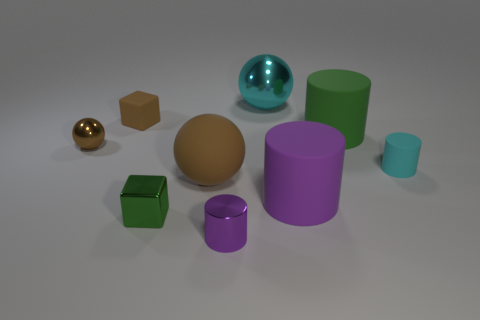There is a small rubber object on the right side of the green rubber thing; is it the same color as the big matte cylinder that is to the right of the large purple rubber object? No, the small rubber object on the right side of the green item is brown, whereas the big matte cylinder to the right of the large purple object is a deep green shade. They are distinct colors with the small object sharing more in common with the earthy tones, and the big cylinder displaying a richer, natural green. 